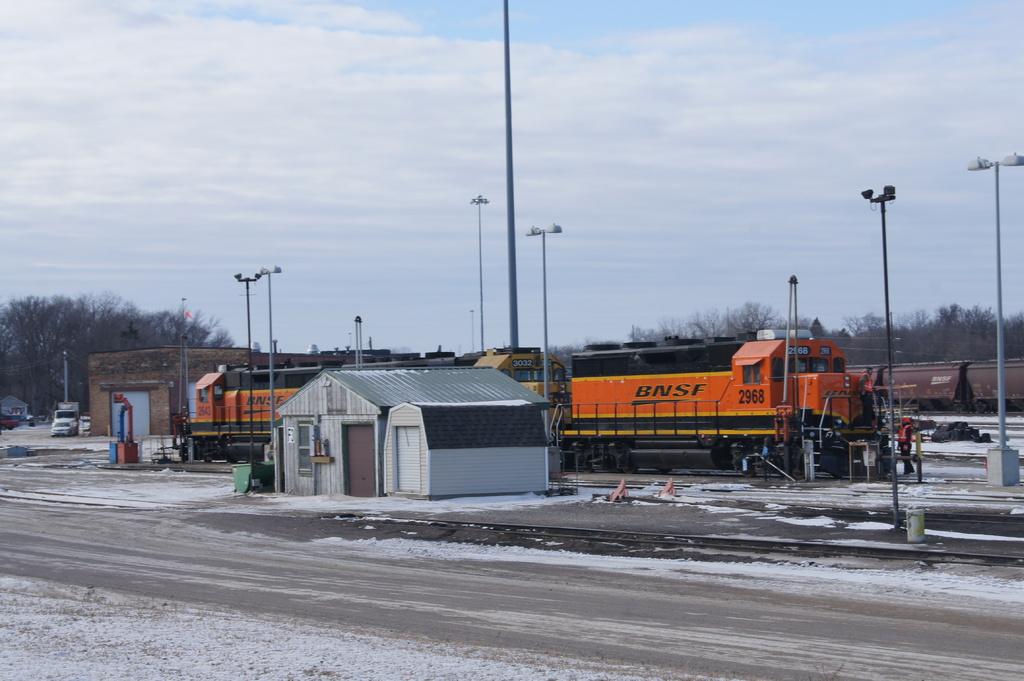What brand is the train?
Your response must be concise. Bnsf. 